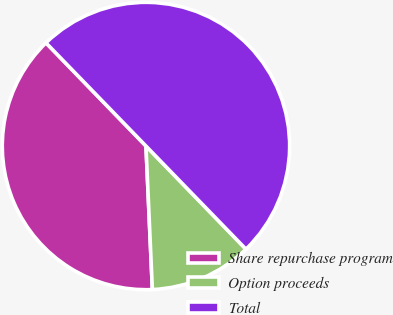Convert chart to OTSL. <chart><loc_0><loc_0><loc_500><loc_500><pie_chart><fcel>Share repurchase program<fcel>Option proceeds<fcel>Total<nl><fcel>38.46%<fcel>11.54%<fcel>50.0%<nl></chart> 